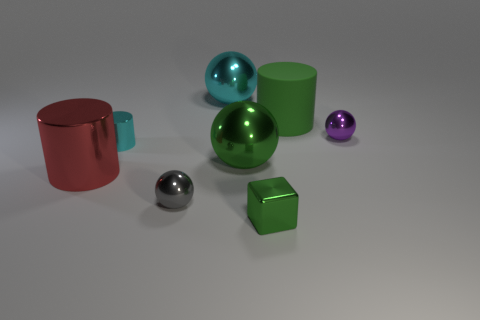Add 2 big purple matte spheres. How many objects exist? 10 Subtract all blocks. How many objects are left? 7 Add 8 tiny gray shiny objects. How many tiny gray shiny objects are left? 9 Add 6 cyan cylinders. How many cyan cylinders exist? 7 Subtract 1 green balls. How many objects are left? 7 Subtract all green rubber blocks. Subtract all green metal spheres. How many objects are left? 7 